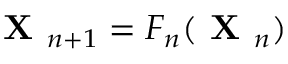<formula> <loc_0><loc_0><loc_500><loc_500>X _ { n + 1 } = F _ { n } ( X _ { n } )</formula> 